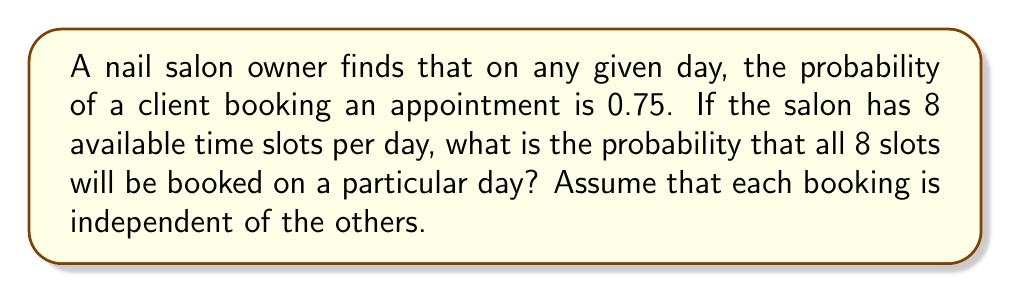Provide a solution to this math problem. Let's approach this step-by-step:

1) We can model this situation using a binomial distribution, where each time slot is a trial with two possible outcomes: booked (success) or not booked (failure).

2) We have:
   - Number of trials (time slots): $n = 8$
   - Probability of success (booking) for each trial: $p = 0.75$
   - We want the probability of all 8 slots being booked, so number of successes: $k = 8$

3) The probability of getting exactly $k$ successes in $n$ trials is given by the binomial probability formula:

   $$ P(X = k) = \binom{n}{k} p^k (1-p)^{n-k} $$

4) Substituting our values:

   $$ P(X = 8) = \binom{8}{8} (0.75)^8 (1-0.75)^{8-8} $$

5) Simplify:
   $$ P(X = 8) = 1 \cdot (0.75)^8 \cdot (0.25)^0 $$

6) Calculate:
   $$ P(X = 8) = (0.75)^8 = 0.1001129150390625 $$

7) This can be rounded to 0.1001 or 10.01%
Answer: 0.1001 or 10.01% 